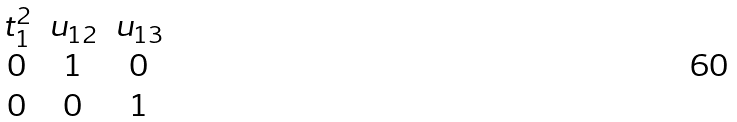Convert formula to latex. <formula><loc_0><loc_0><loc_500><loc_500>\begin{matrix} t ^ { 2 } _ { 1 } & u _ { 1 2 } & u _ { 1 3 } \\ 0 & 1 & 0 \\ 0 & 0 & 1 \end{matrix}</formula> 